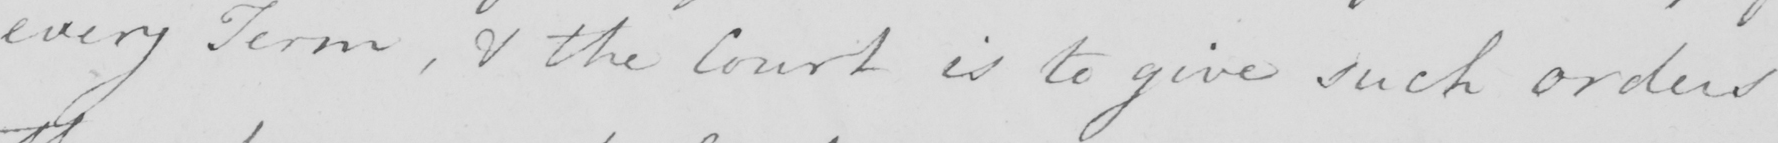Transcribe the text shown in this historical manuscript line. every Term , & the Court is to give such orders 